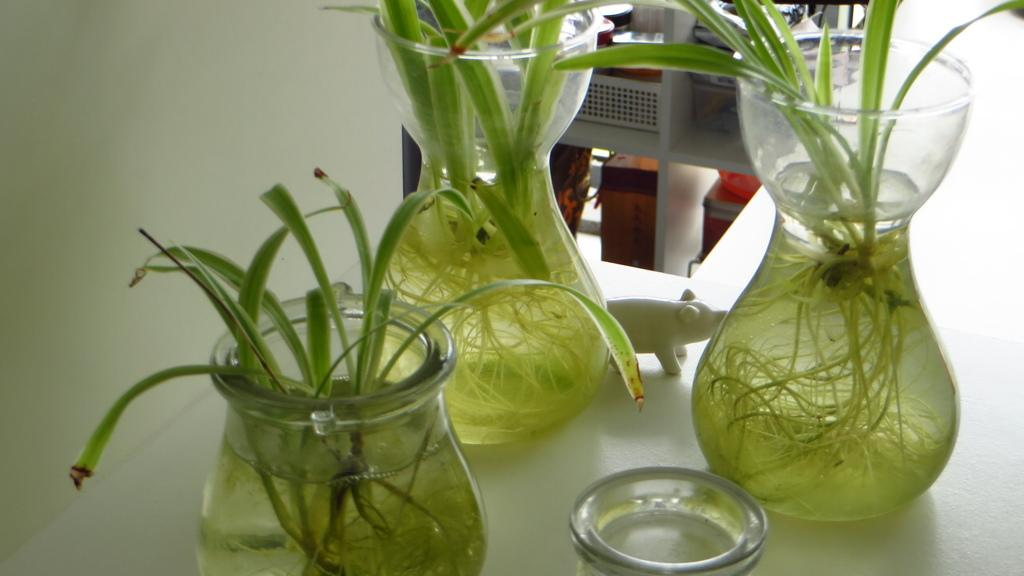What type of plants are in the flask in the foreground of the image? There are water plants in a flask in the foreground of the image. What can be seen on the table in the image? There is a depiction of a pig on a table in the image. What type of blade is being used to cut the zipper in the image? There is no blade or zipper present in the image. 